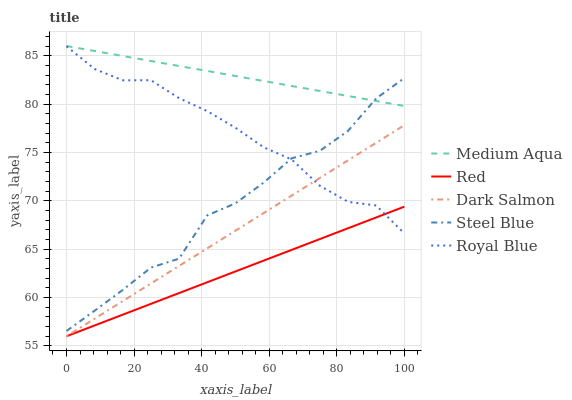Does Red have the minimum area under the curve?
Answer yes or no. Yes. Does Medium Aqua have the maximum area under the curve?
Answer yes or no. Yes. Does Dark Salmon have the minimum area under the curve?
Answer yes or no. No. Does Dark Salmon have the maximum area under the curve?
Answer yes or no. No. Is Medium Aqua the smoothest?
Answer yes or no. Yes. Is Steel Blue the roughest?
Answer yes or no. Yes. Is Dark Salmon the smoothest?
Answer yes or no. No. Is Dark Salmon the roughest?
Answer yes or no. No. Does Dark Salmon have the lowest value?
Answer yes or no. Yes. Does Medium Aqua have the lowest value?
Answer yes or no. No. Does Medium Aqua have the highest value?
Answer yes or no. Yes. Does Dark Salmon have the highest value?
Answer yes or no. No. Is Red less than Steel Blue?
Answer yes or no. Yes. Is Medium Aqua greater than Dark Salmon?
Answer yes or no. Yes. Does Medium Aqua intersect Steel Blue?
Answer yes or no. Yes. Is Medium Aqua less than Steel Blue?
Answer yes or no. No. Is Medium Aqua greater than Steel Blue?
Answer yes or no. No. Does Red intersect Steel Blue?
Answer yes or no. No. 